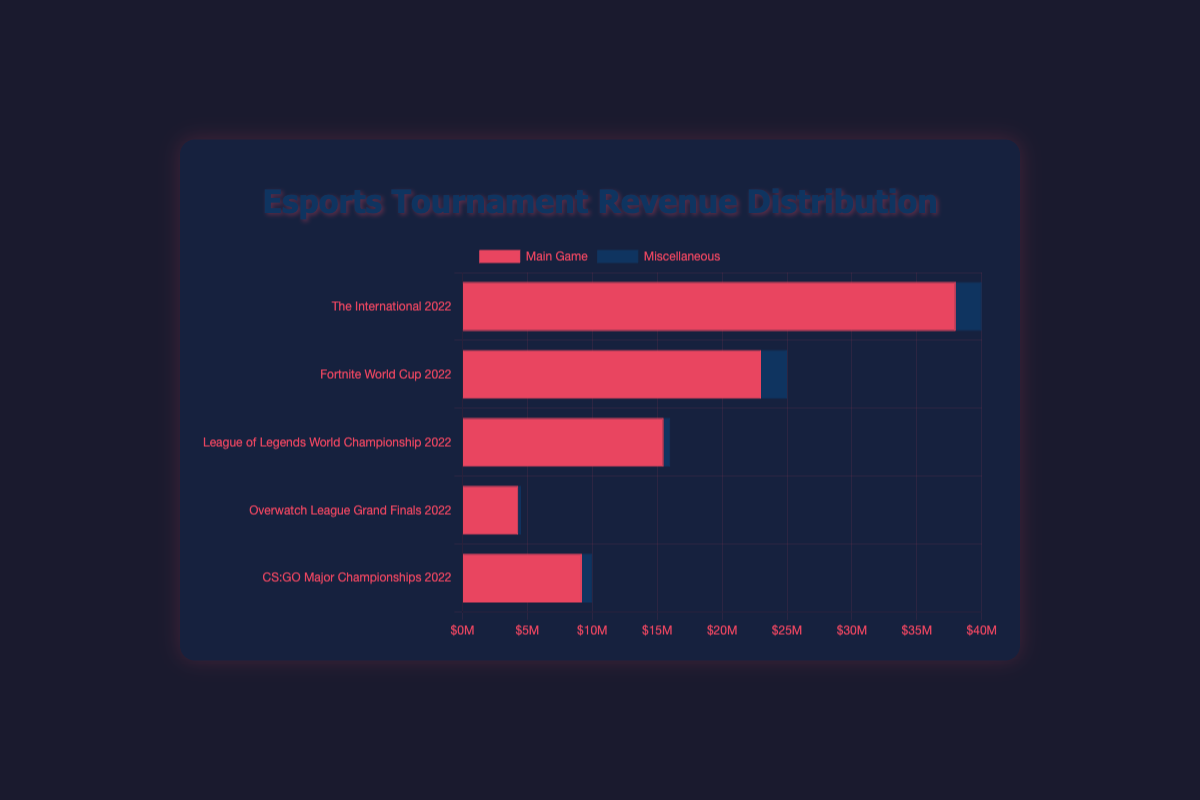How much revenue did the top two revenue-generating tournaments make in total? To find the total revenue of the top two revenue-generating tournaments, add the total revenue of "The International 2022" ($40,000,000) and "Fortnite World Cup 2022" ($25,000,000). The total is $40,000,000 + $25,000,000 = $65,000,000.
Answer: $65,000,000 Which tournament had the highest miscellaneous revenue? By comparing the miscellaneous revenue segments of all tournaments, "The International 2022" had the highest miscellaneous revenue, amounting to $2,000,000.
Answer: The International 2022 How much more revenue did "Fortnite World Cup 2022" generate from Fortnite compared to the total revenue of the "Overwatch League Grand Finals 2022"? Compare the revenue from Fortnite ($23,000,000) to the total revenue of the "Overwatch League Grand Finals 2022" ($4,500,000). The difference is $23,000,000 - $4,500,000 = $18,500,000.
Answer: $18,500,000 How much less revenue did "CS:GO Major Championships 2022" generate in total compared to "The International 2022"? Subtract the total revenue of "CS:GO Major Championships 2022" ($10,000,000) from "The International 2022" ($40,000,000). The difference is $40,000,000 - $10,000,000 = $30,000,000.
Answer: $30,000,000 Which tournament had the smallest proportion of its total revenue coming from miscellaneous games? By comparing the miscellaneous revenue as a proportion of the total for each tournament, "League of Legends World Championship 2022" had the smallest proportion, with $500,000 out of $16,000,000.
Answer: League of Legends World Championship 2022 What is the combined total revenue of the tournaments with the smallest and largest total revenues? The smallest total revenue is "Overwatch League Grand Finals 2022" ($4,500,000) and the largest is "The International 2022" ($40,000,000). Their combined total revenue is $4,500,000 + $40,000,000 = $44,500,000.
Answer: $44,500,000 Which game's revenue made up the largest part of its respective tournament's total revenue? "League of Legends" made up $15,500,000 of the $16,000,000 total revenue for "League of Legends World Championship 2022", which is the highest proportion (approximately 96.9%).
Answer: League of Legends 